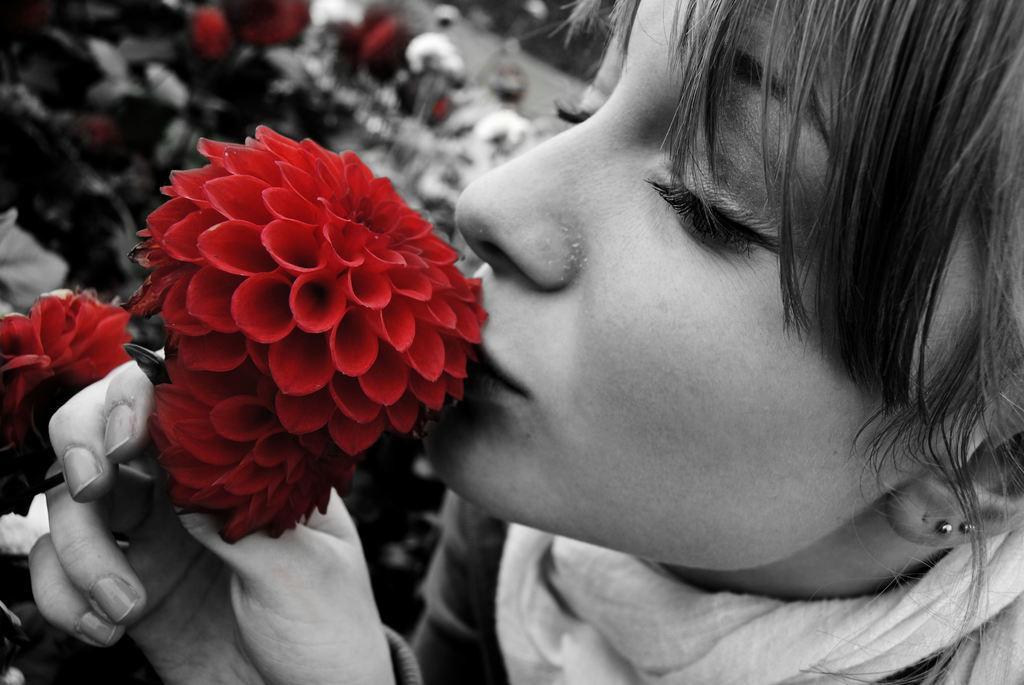Could you give a brief overview of what you see in this image? It looks like a black and white picture. We can see a woman is holding a flower and behind the woman there are some blurred items. 